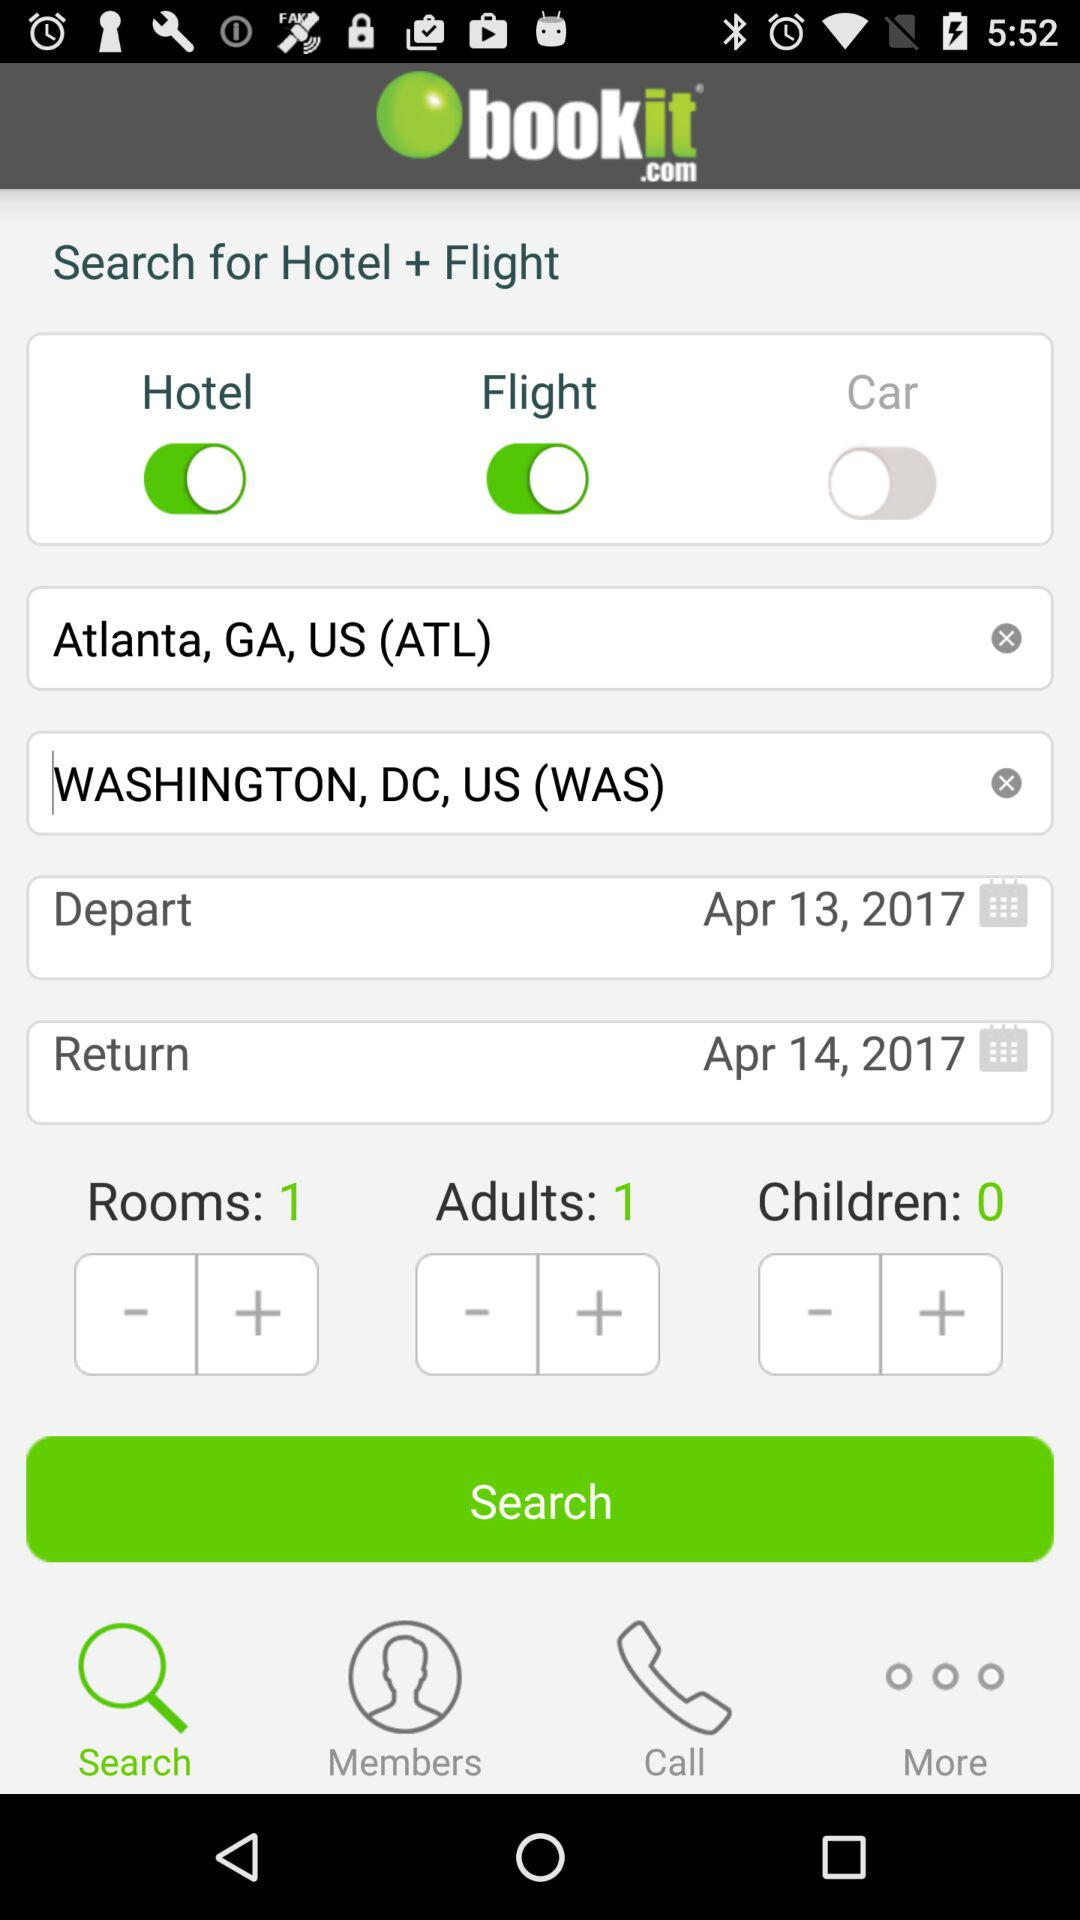How many adults are there? There is only 1 adult. 